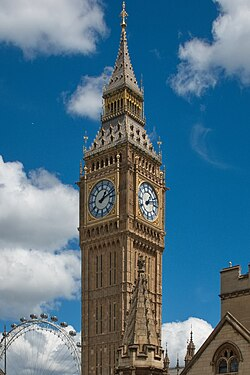Can you describe more historical context about this landmark? Certainly! Big Ben is the nickname for the Great Bell of the clock at the north end of the Palace of Westminster in London, but it is often extended to refer to both the clock and the clock tower. Completed in 1859, it was designed by architect Augustus Pugin in a neo-gothic style. The tower itself is officially known as the Elizabeth Tower, renamed to commemorate Queen Elizabeth II's Diamond Jubilee in 2012. For over 160 years, Big Ben has stood as a symbol of British politics and culture, marking the passage of time for residents and tourists alike. 